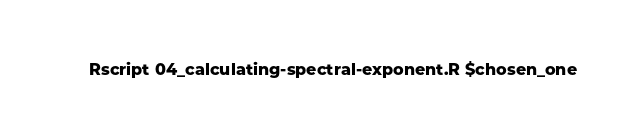Convert code to text. <code><loc_0><loc_0><loc_500><loc_500><_Bash_>Rscript 04_calculating-spectral-exponent.R $chosen_one

</code> 